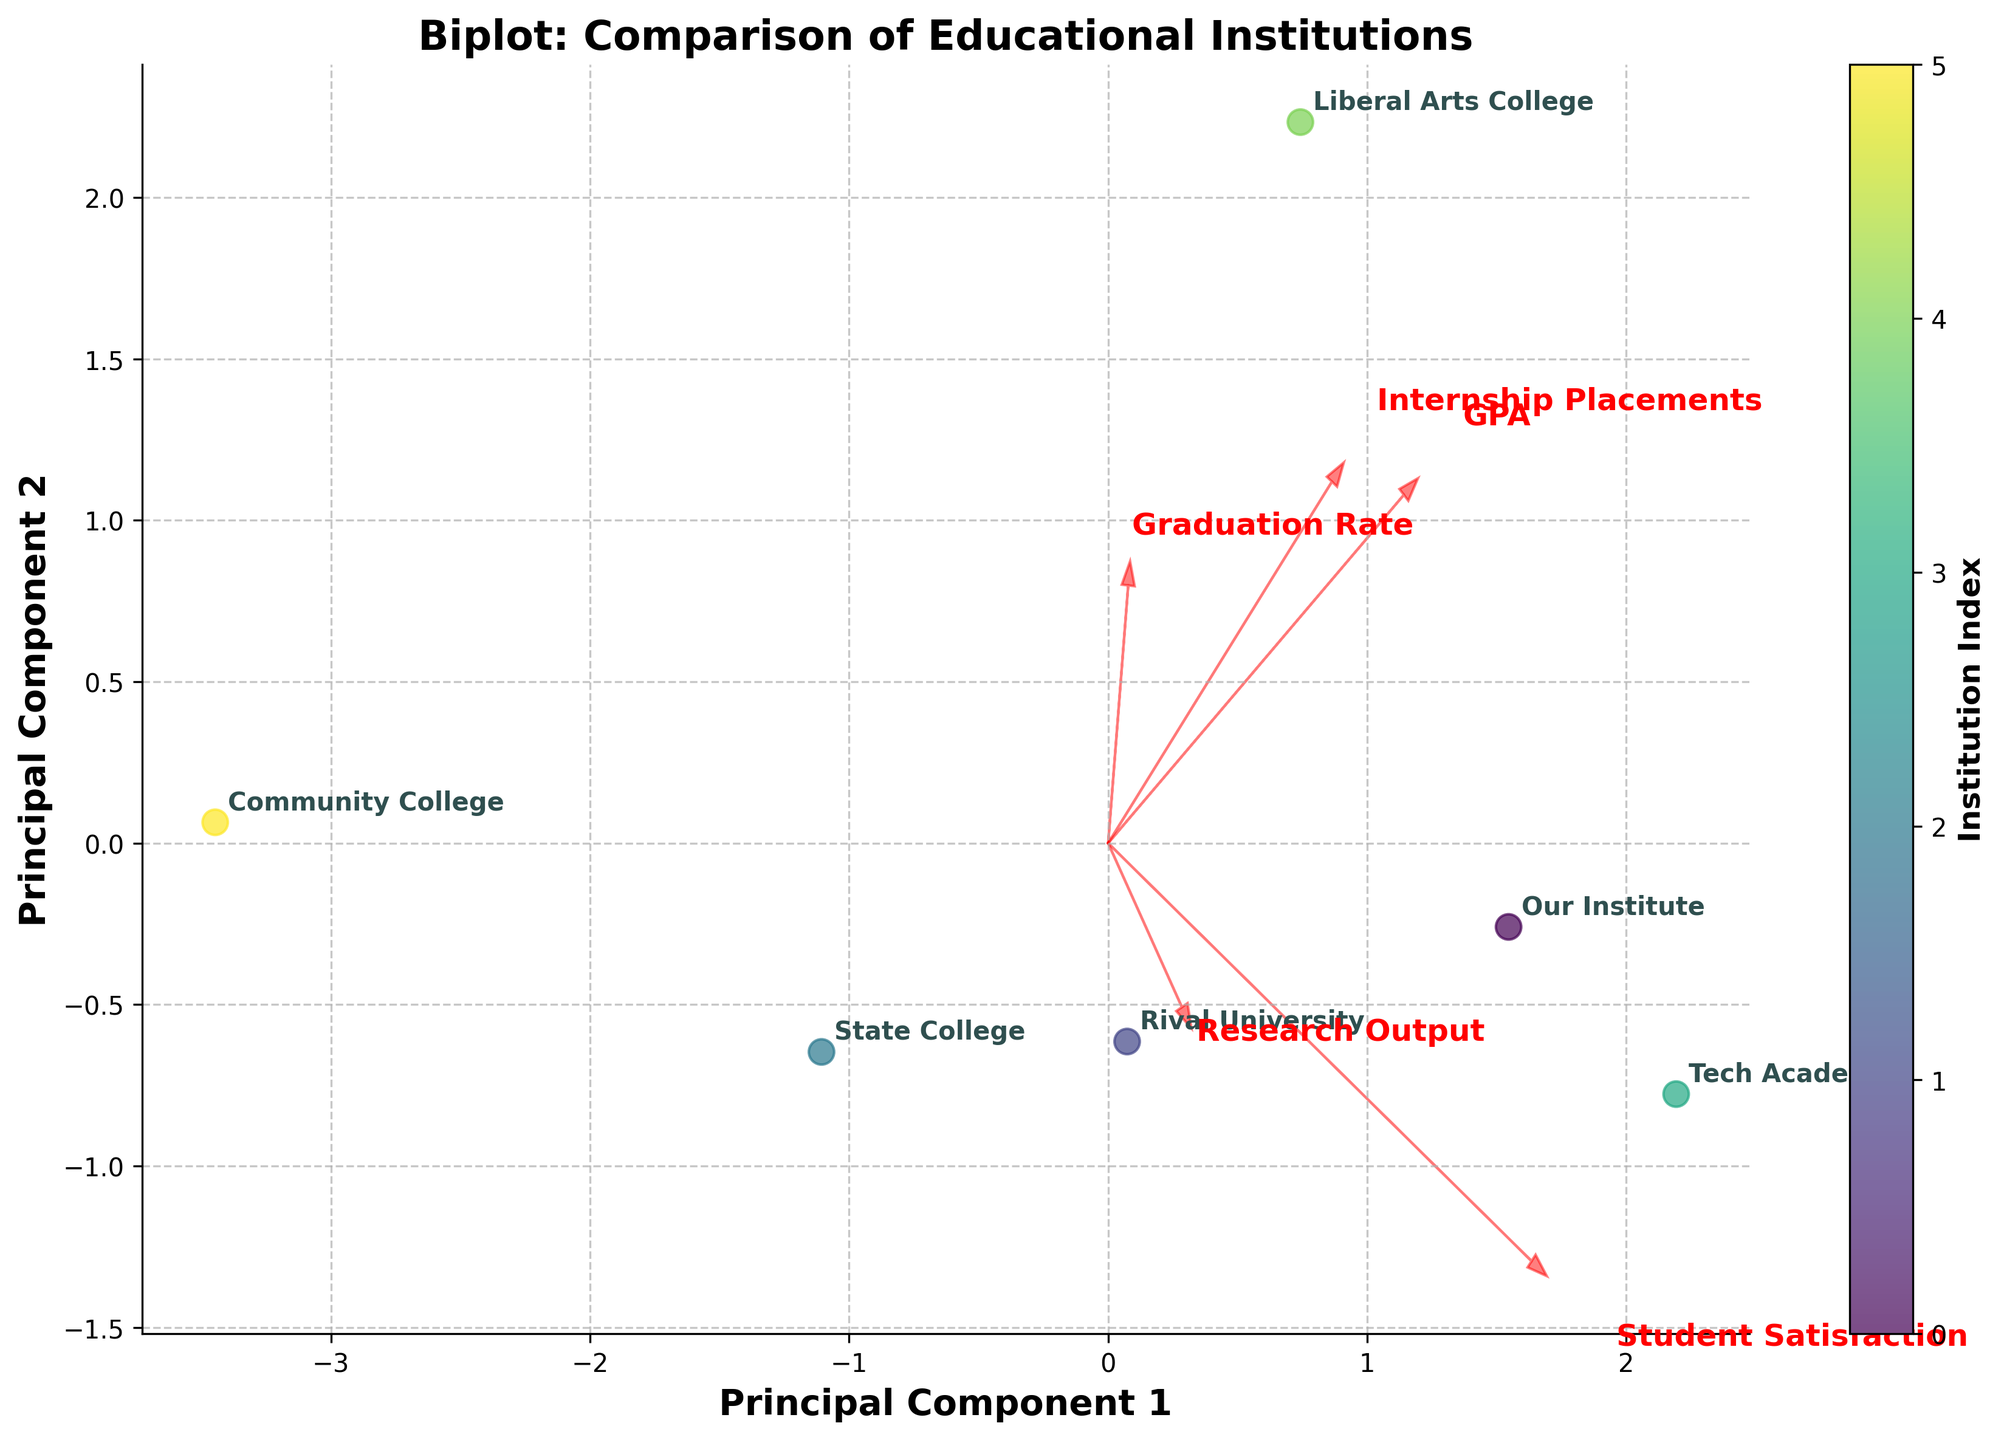What is the title of the figure? The title of the figure is written prominently at the top of the plot in large bold text. It reads "Biplot: Comparison of Educational Institutions".
Answer: Biplot: Comparison of Educational Institutions Which principal component is labeled on the x-axis? The x-axis label is identified by looking at the text directly under the horizontal axis. It reads "Principal Component 1".
Answer: Principal Component 1 How many institutions are represented in the plot? The plot displays data points for each institution, identified by annotated institution names. By counting the different names, we find there are six institutions represented: Our Institute, Rival University, State College, Tech Academy, Liberal Arts College, and Community College.
Answer: 6 Which institution has the highest value in the "Student Satisfaction" feature vector, based on the arrows? The feature vectors are represented by arrows, and the "Student Satisfaction" arrow points towards the direction where the institution with the highest value lies. The longest arrow for "Student Satisfaction" points towards "Liberal Arts College", indicating it has the highest satisfaction score.
Answer: Liberal Arts College What does PC1 mainly represent in terms of features? PC1 can be interpreted based on the directions and lengths of the arrows pointing towards it. Features with arrows pointing significantly in the direction of PC1 have more influence on this component. For PC1, there is a strong influence of "GPA", "Graduation Rate", and "Internship Placements".
Answer: GPA, Graduation Rate, Internship Placements Which institution appears closest to the origin in the plot? The origin is the point (0, 0) in the PCA transformed space. By looking at the data points, "State College" appears to be closest to the origin, suggesting it is the most average in terms of the combined principal components.
Answer: State College How does "Research Output" contribute to PC2? The direction of the arrow for "Research Output" relative to the PC2 axis shows that this feature has a significant positive contribution to PC2. This can be observed from the almost vertical arrow pointing upwards.
Answer: Positive contribution Which institutions are closely clustered together? By inspecting the scatter points and their annotations, "Our Institute" and "Tech Academy" are notably close to each other, suggesting similar scores along the principal components.
Answer: Our Institute, Tech Academy Which institution is an outlier and why? An outlier can be identified as a data point far from the cluster of other points. "Tech Academy" appears as an outlier due to its significant separation from the main group, likely due to its high scores in internship placements and research output.
Answer: Tech Academy Is there any institution that has a strong negative projection on PC1? To find an institution with a strong negative projection on PC1, look for the data point farthest to the left. "Community College" is positioned the farthest left, indicating it has a strong negative projection on PC1.
Answer: Community College 